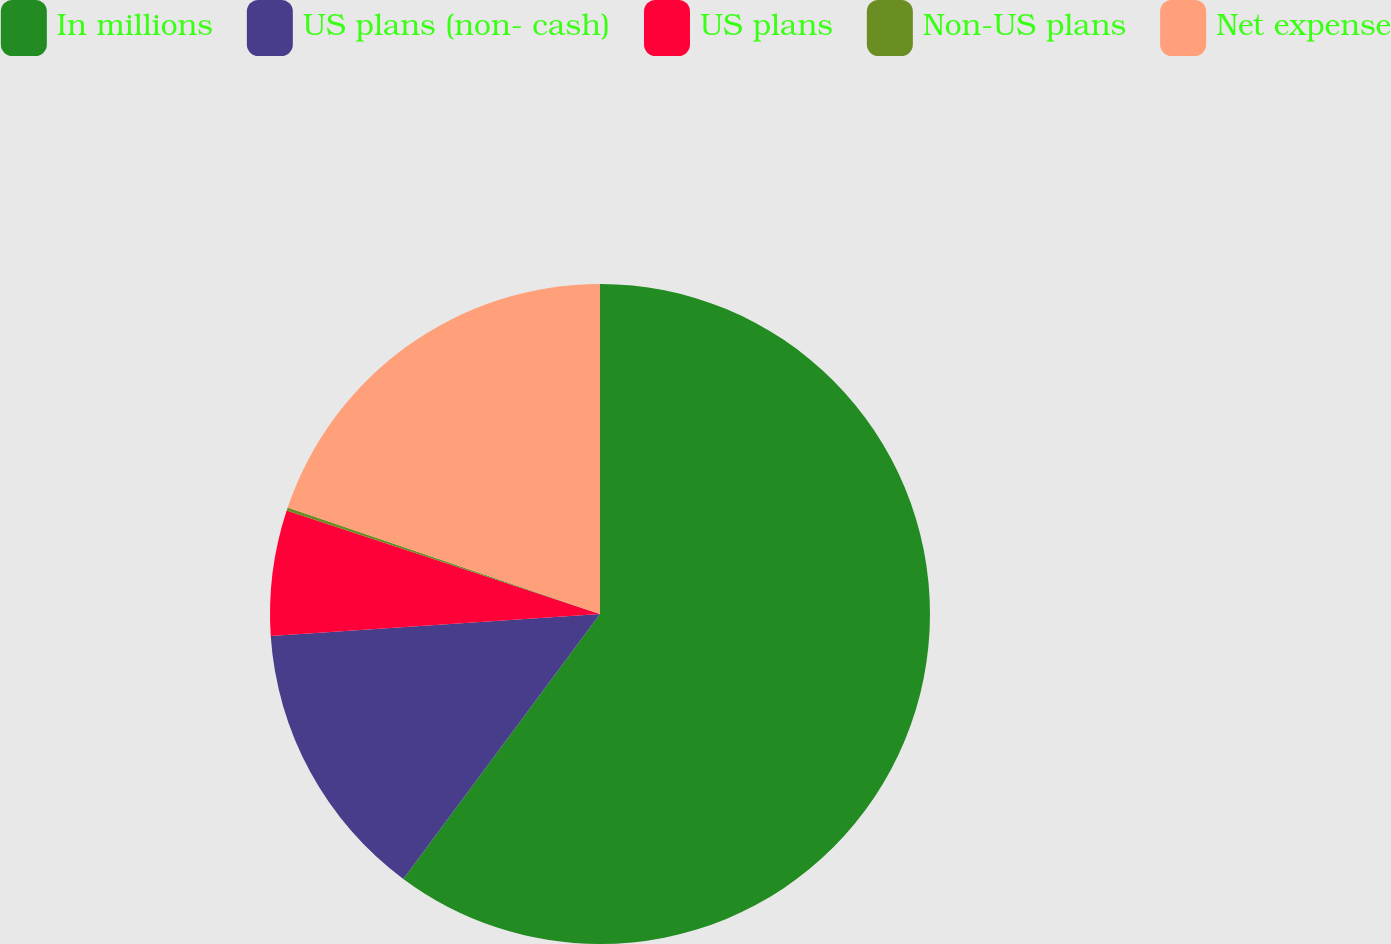<chart> <loc_0><loc_0><loc_500><loc_500><pie_chart><fcel>In millions<fcel>US plans (non- cash)<fcel>US plans<fcel>Non-US plans<fcel>Net expense<nl><fcel>60.17%<fcel>13.77%<fcel>6.15%<fcel>0.15%<fcel>19.77%<nl></chart> 